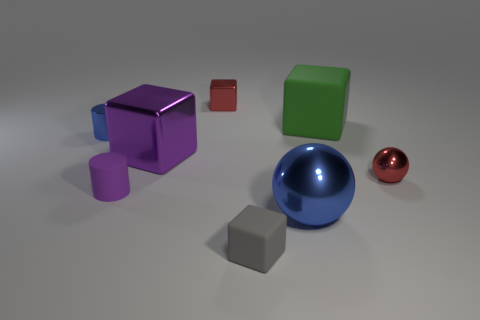Add 2 red things. How many objects exist? 10 Subtract all balls. How many objects are left? 6 Subtract 0 purple balls. How many objects are left? 8 Subtract all big metallic cubes. Subtract all purple shiny objects. How many objects are left? 6 Add 4 blue shiny spheres. How many blue shiny spheres are left? 5 Add 3 large brown matte cubes. How many large brown matte cubes exist? 3 